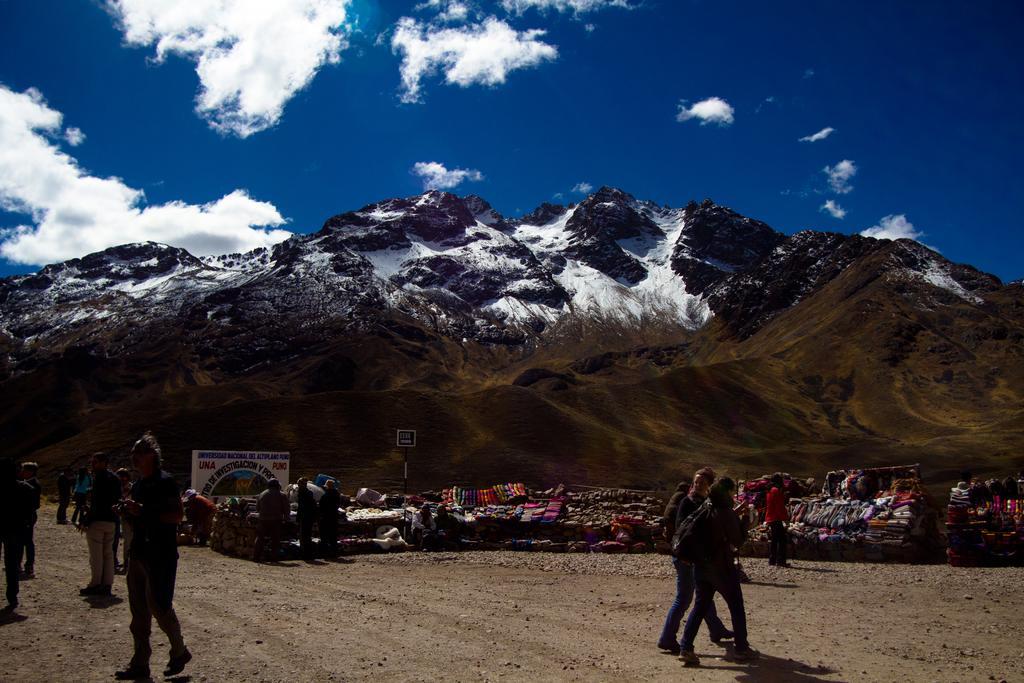Can you describe this image briefly? In this picture we can see few people, in the background we can see few clothes, hoarding, hills and clouds. 